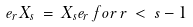<formula> <loc_0><loc_0><loc_500><loc_500>e _ { r } X _ { s } \, = \, X _ { s } e _ { r } \, f o r \, r \, < \, s - 1</formula> 